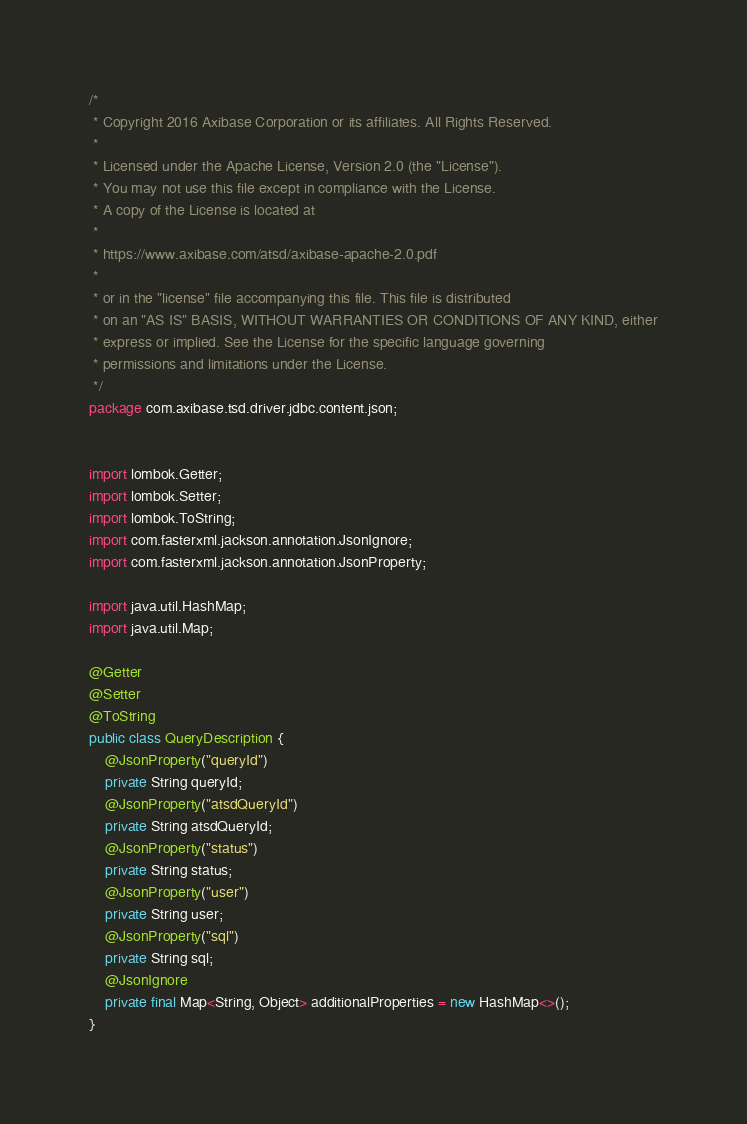Convert code to text. <code><loc_0><loc_0><loc_500><loc_500><_Java_>/*
 * Copyright 2016 Axibase Corporation or its affiliates. All Rights Reserved.
 *
 * Licensed under the Apache License, Version 2.0 (the "License").
 * You may not use this file except in compliance with the License.
 * A copy of the License is located at
 *
 * https://www.axibase.com/atsd/axibase-apache-2.0.pdf
 *
 * or in the "license" file accompanying this file. This file is distributed
 * on an "AS IS" BASIS, WITHOUT WARRANTIES OR CONDITIONS OF ANY KIND, either
 * express or implied. See the License for the specific language governing
 * permissions and limitations under the License.
 */
package com.axibase.tsd.driver.jdbc.content.json;


import lombok.Getter;
import lombok.Setter;
import lombok.ToString;
import com.fasterxml.jackson.annotation.JsonIgnore;
import com.fasterxml.jackson.annotation.JsonProperty;

import java.util.HashMap;
import java.util.Map;

@Getter
@Setter
@ToString
public class QueryDescription {
    @JsonProperty("queryId")
    private String queryId;
    @JsonProperty("atsdQueryId")
    private String atsdQueryId;
    @JsonProperty("status")
    private String status;
    @JsonProperty("user")
    private String user;
    @JsonProperty("sql")
    private String sql;
    @JsonIgnore
    private final Map<String, Object> additionalProperties = new HashMap<>();
}
</code> 